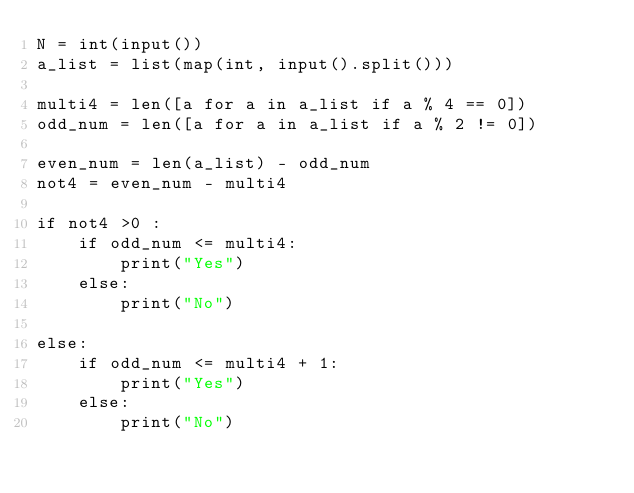<code> <loc_0><loc_0><loc_500><loc_500><_Python_>N = int(input())
a_list = list(map(int, input().split()))

multi4 = len([a for a in a_list if a % 4 == 0])
odd_num = len([a for a in a_list if a % 2 != 0])

even_num = len(a_list) - odd_num
not4 = even_num - multi4

if not4 >0 :
    if odd_num <= multi4:
        print("Yes")
    else:
        print("No")

else:
    if odd_num <= multi4 + 1:
        print("Yes")
    else:
        print("No")
</code> 